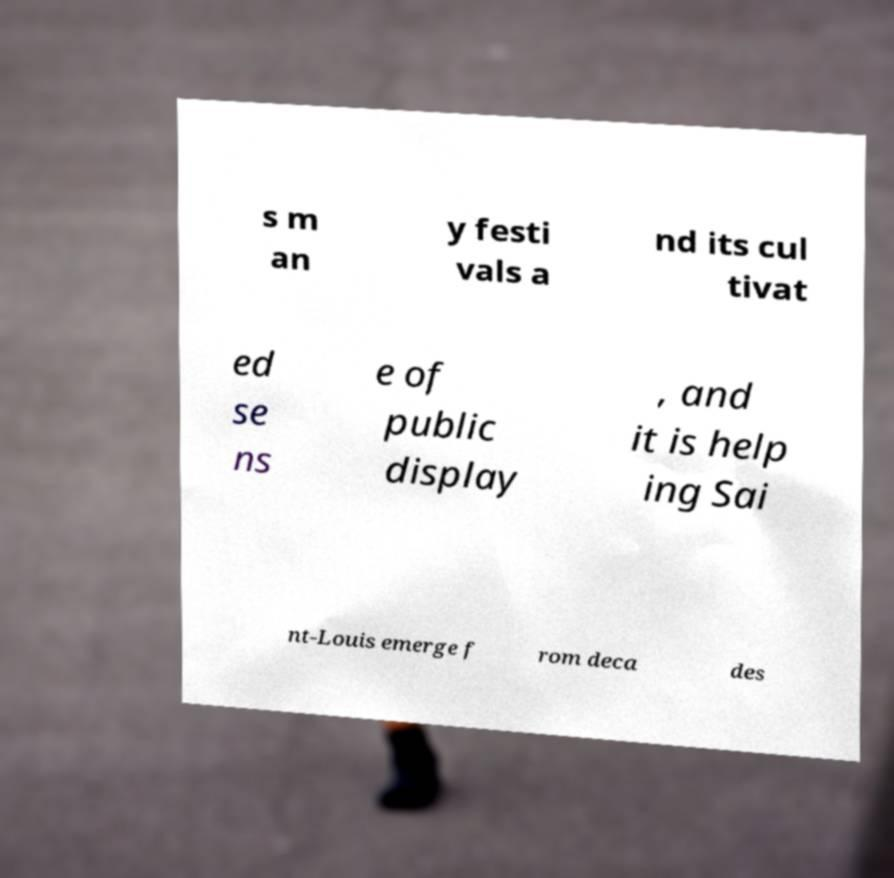There's text embedded in this image that I need extracted. Can you transcribe it verbatim? s m an y festi vals a nd its cul tivat ed se ns e of public display , and it is help ing Sai nt-Louis emerge f rom deca des 